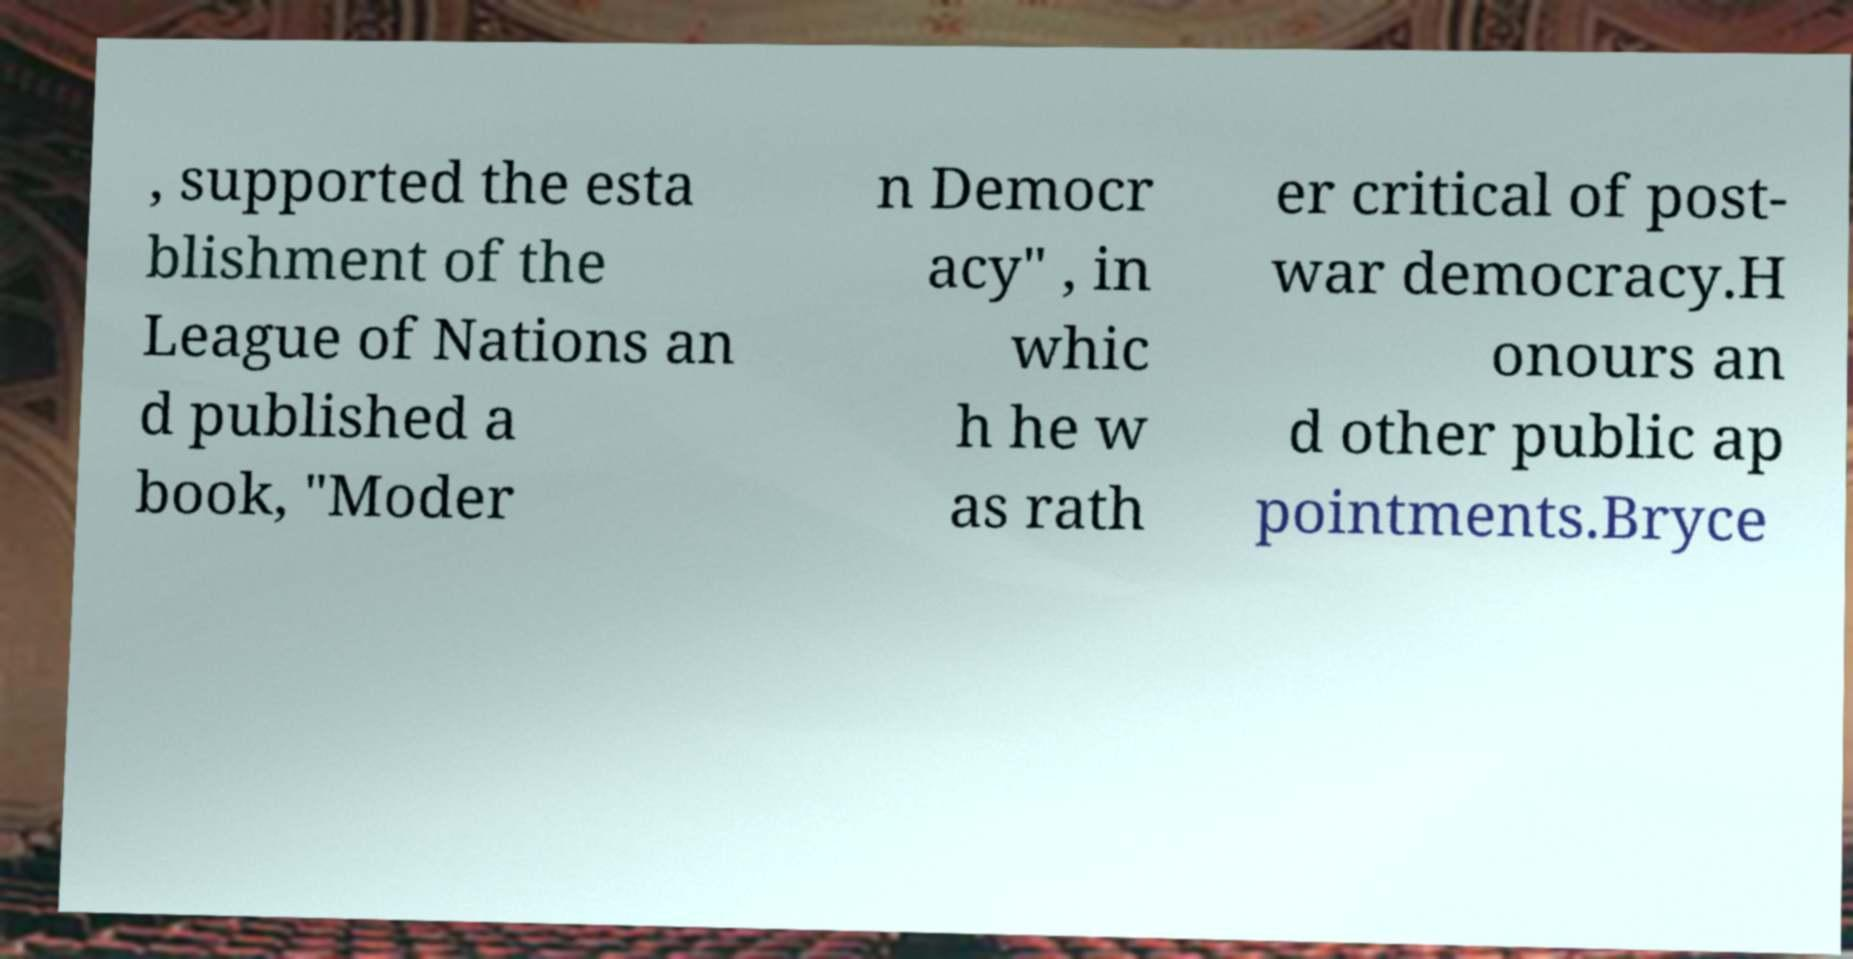Can you accurately transcribe the text from the provided image for me? , supported the esta blishment of the League of Nations an d published a book, "Moder n Democr acy" , in whic h he w as rath er critical of post- war democracy.H onours an d other public ap pointments.Bryce 